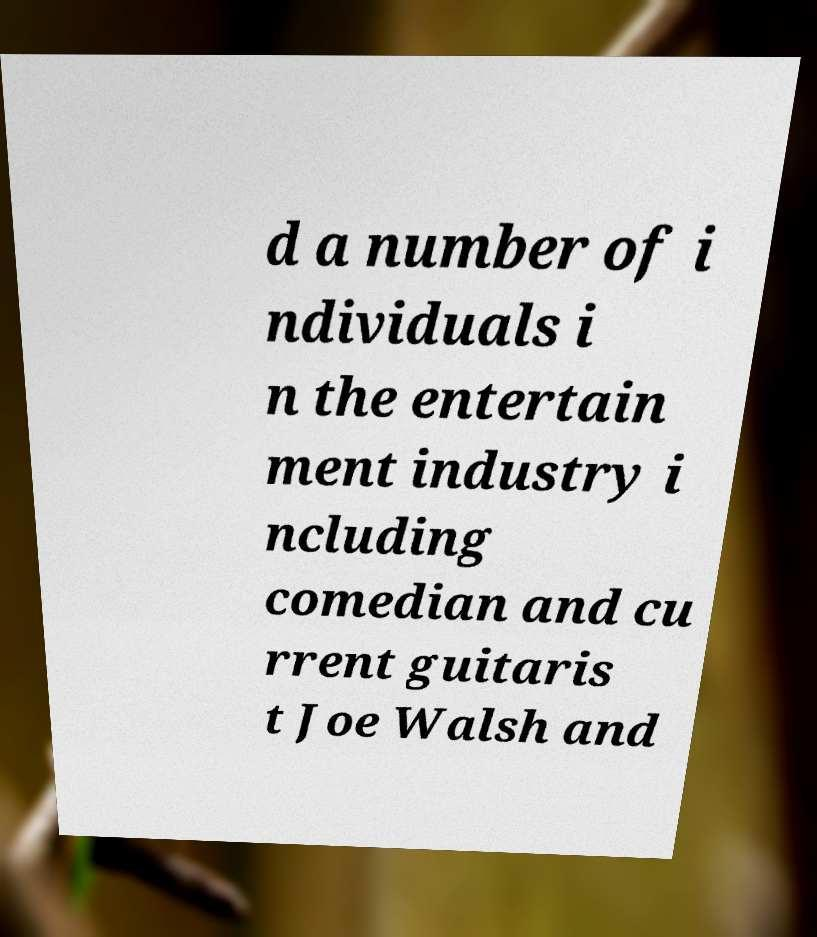Can you accurately transcribe the text from the provided image for me? d a number of i ndividuals i n the entertain ment industry i ncluding comedian and cu rrent guitaris t Joe Walsh and 